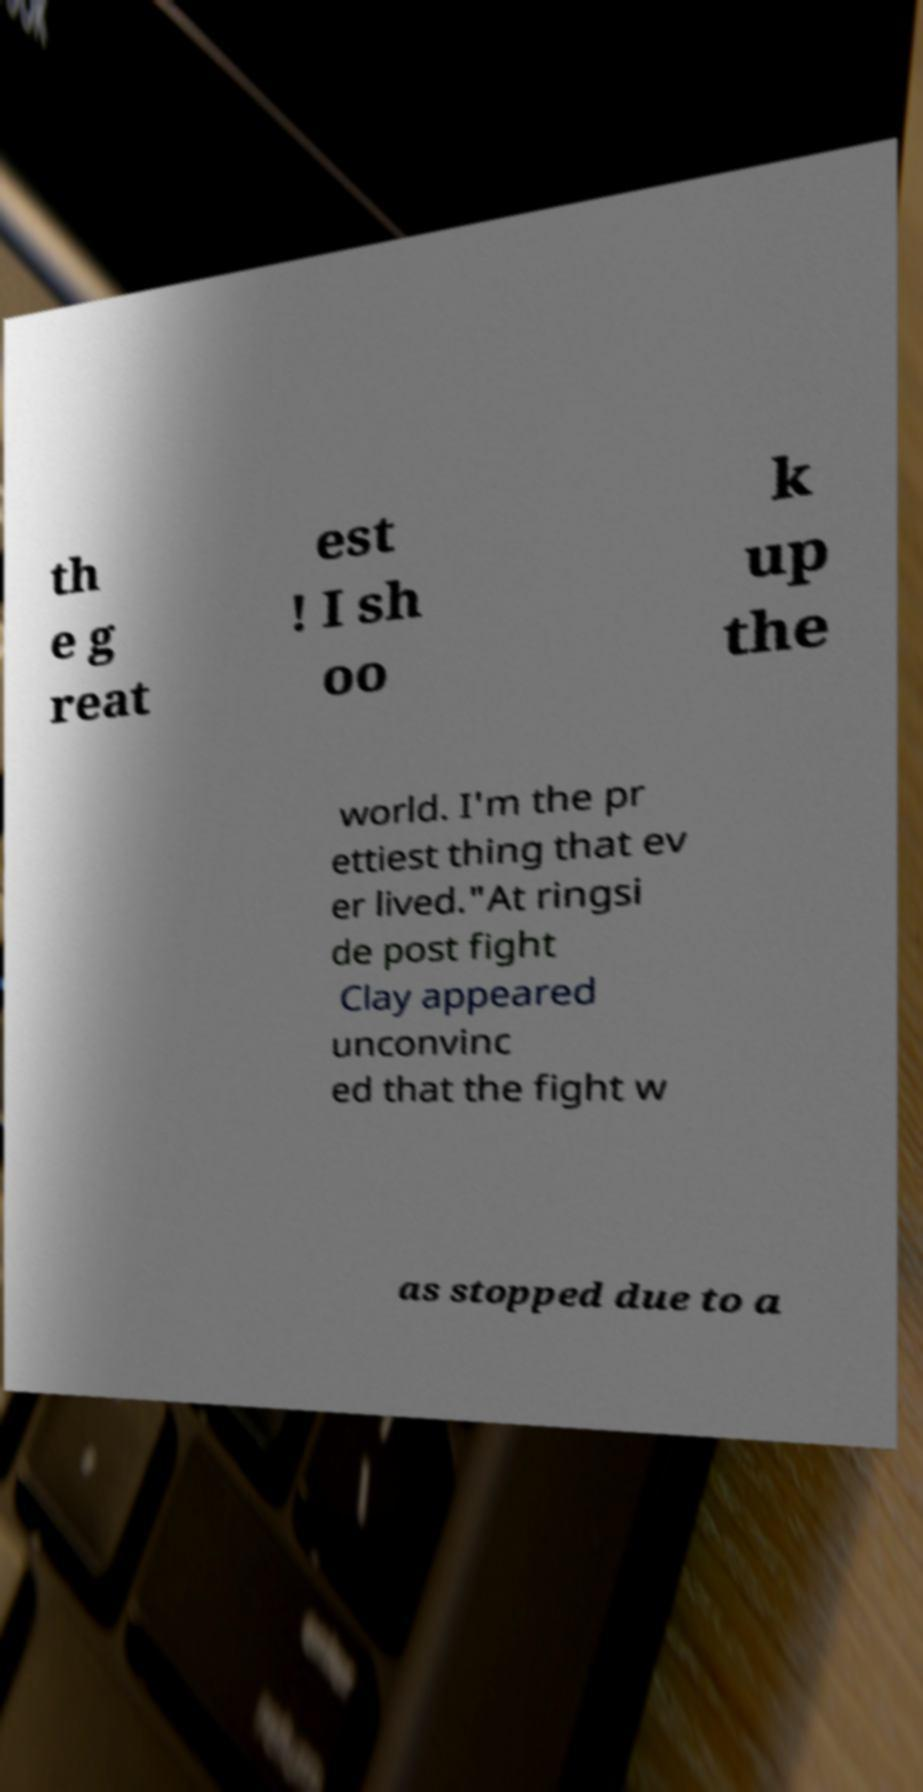I need the written content from this picture converted into text. Can you do that? th e g reat est ! I sh oo k up the world. I'm the pr ettiest thing that ev er lived."At ringsi de post fight Clay appeared unconvinc ed that the fight w as stopped due to a 